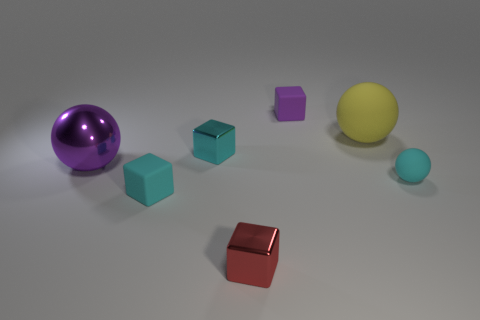Subtract all rubber balls. How many balls are left? 1 Subtract all blue cylinders. How many cyan cubes are left? 2 Subtract all spheres. How many objects are left? 4 Add 2 small red objects. How many objects exist? 9 Subtract all yellow spheres. How many spheres are left? 2 Subtract 3 spheres. How many spheres are left? 0 Subtract all purple balls. Subtract all brown cylinders. How many balls are left? 2 Subtract all blocks. Subtract all tiny cyan objects. How many objects are left? 0 Add 2 cyan balls. How many cyan balls are left? 3 Add 2 small red rubber spheres. How many small red rubber spheres exist? 2 